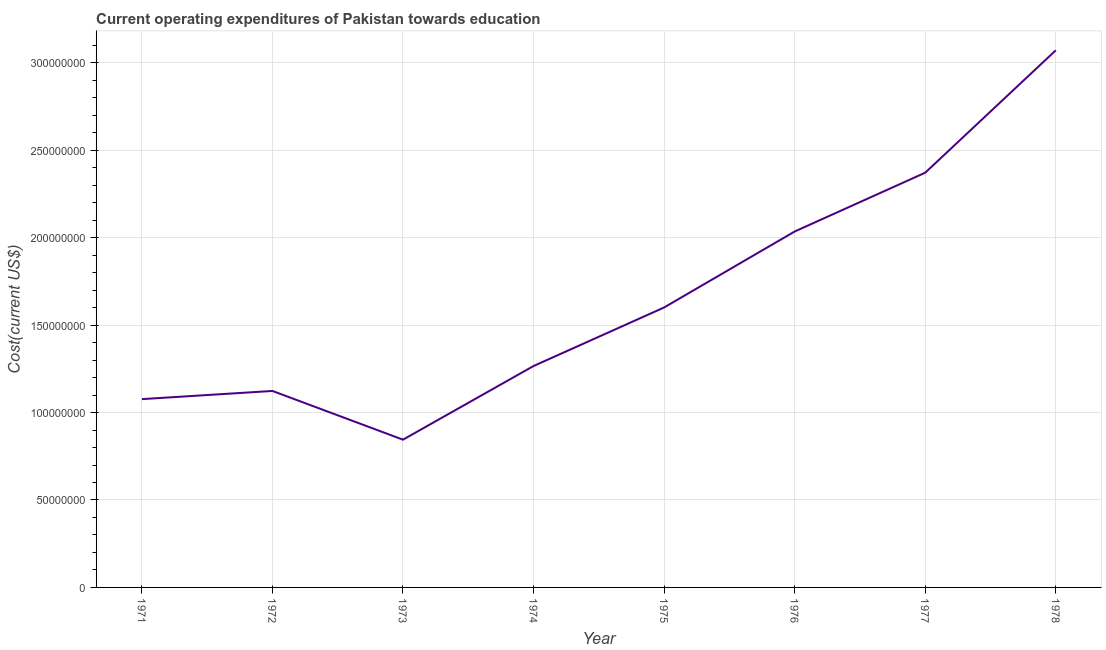What is the education expenditure in 1975?
Offer a very short reply. 1.60e+08. Across all years, what is the maximum education expenditure?
Provide a short and direct response. 3.07e+08. Across all years, what is the minimum education expenditure?
Give a very brief answer. 8.45e+07. In which year was the education expenditure maximum?
Give a very brief answer. 1978. In which year was the education expenditure minimum?
Make the answer very short. 1973. What is the sum of the education expenditure?
Your answer should be compact. 1.34e+09. What is the difference between the education expenditure in 1973 and 1976?
Ensure brevity in your answer.  -1.19e+08. What is the average education expenditure per year?
Your response must be concise. 1.67e+08. What is the median education expenditure?
Provide a short and direct response. 1.43e+08. In how many years, is the education expenditure greater than 220000000 US$?
Offer a terse response. 2. What is the ratio of the education expenditure in 1974 to that in 1977?
Keep it short and to the point. 0.53. Is the education expenditure in 1971 less than that in 1972?
Provide a short and direct response. Yes. What is the difference between the highest and the second highest education expenditure?
Make the answer very short. 7.00e+07. Is the sum of the education expenditure in 1972 and 1974 greater than the maximum education expenditure across all years?
Your response must be concise. No. What is the difference between the highest and the lowest education expenditure?
Your answer should be very brief. 2.23e+08. Does the education expenditure monotonically increase over the years?
Make the answer very short. No. How many lines are there?
Your answer should be very brief. 1. How many years are there in the graph?
Keep it short and to the point. 8. What is the difference between two consecutive major ticks on the Y-axis?
Keep it short and to the point. 5.00e+07. Does the graph contain any zero values?
Keep it short and to the point. No. What is the title of the graph?
Provide a short and direct response. Current operating expenditures of Pakistan towards education. What is the label or title of the Y-axis?
Your answer should be compact. Cost(current US$). What is the Cost(current US$) of 1971?
Provide a short and direct response. 1.08e+08. What is the Cost(current US$) of 1972?
Offer a terse response. 1.12e+08. What is the Cost(current US$) in 1973?
Your answer should be very brief. 8.45e+07. What is the Cost(current US$) of 1974?
Provide a short and direct response. 1.27e+08. What is the Cost(current US$) of 1975?
Offer a very short reply. 1.60e+08. What is the Cost(current US$) in 1976?
Offer a very short reply. 2.04e+08. What is the Cost(current US$) of 1977?
Provide a succinct answer. 2.37e+08. What is the Cost(current US$) of 1978?
Provide a short and direct response. 3.07e+08. What is the difference between the Cost(current US$) in 1971 and 1972?
Provide a succinct answer. -4.68e+06. What is the difference between the Cost(current US$) in 1971 and 1973?
Offer a terse response. 2.32e+07. What is the difference between the Cost(current US$) in 1971 and 1974?
Provide a short and direct response. -1.89e+07. What is the difference between the Cost(current US$) in 1971 and 1975?
Give a very brief answer. -5.24e+07. What is the difference between the Cost(current US$) in 1971 and 1976?
Your answer should be very brief. -9.58e+07. What is the difference between the Cost(current US$) in 1971 and 1977?
Your answer should be compact. -1.29e+08. What is the difference between the Cost(current US$) in 1971 and 1978?
Provide a succinct answer. -1.99e+08. What is the difference between the Cost(current US$) in 1972 and 1973?
Ensure brevity in your answer.  2.79e+07. What is the difference between the Cost(current US$) in 1972 and 1974?
Offer a terse response. -1.43e+07. What is the difference between the Cost(current US$) in 1972 and 1975?
Your response must be concise. -4.77e+07. What is the difference between the Cost(current US$) in 1972 and 1976?
Your answer should be very brief. -9.12e+07. What is the difference between the Cost(current US$) in 1972 and 1977?
Provide a succinct answer. -1.25e+08. What is the difference between the Cost(current US$) in 1972 and 1978?
Your answer should be very brief. -1.95e+08. What is the difference between the Cost(current US$) in 1973 and 1974?
Your answer should be compact. -4.21e+07. What is the difference between the Cost(current US$) in 1973 and 1975?
Offer a very short reply. -7.56e+07. What is the difference between the Cost(current US$) in 1973 and 1976?
Offer a terse response. -1.19e+08. What is the difference between the Cost(current US$) in 1973 and 1977?
Make the answer very short. -1.53e+08. What is the difference between the Cost(current US$) in 1973 and 1978?
Provide a succinct answer. -2.23e+08. What is the difference between the Cost(current US$) in 1974 and 1975?
Offer a very short reply. -3.35e+07. What is the difference between the Cost(current US$) in 1974 and 1976?
Ensure brevity in your answer.  -7.69e+07. What is the difference between the Cost(current US$) in 1974 and 1977?
Provide a short and direct response. -1.11e+08. What is the difference between the Cost(current US$) in 1974 and 1978?
Your answer should be very brief. -1.81e+08. What is the difference between the Cost(current US$) in 1975 and 1976?
Your response must be concise. -4.34e+07. What is the difference between the Cost(current US$) in 1975 and 1977?
Ensure brevity in your answer.  -7.71e+07. What is the difference between the Cost(current US$) in 1975 and 1978?
Ensure brevity in your answer.  -1.47e+08. What is the difference between the Cost(current US$) in 1976 and 1977?
Offer a very short reply. -3.36e+07. What is the difference between the Cost(current US$) in 1976 and 1978?
Give a very brief answer. -1.04e+08. What is the difference between the Cost(current US$) in 1977 and 1978?
Offer a very short reply. -7.00e+07. What is the ratio of the Cost(current US$) in 1971 to that in 1972?
Give a very brief answer. 0.96. What is the ratio of the Cost(current US$) in 1971 to that in 1973?
Keep it short and to the point. 1.27. What is the ratio of the Cost(current US$) in 1971 to that in 1975?
Make the answer very short. 0.67. What is the ratio of the Cost(current US$) in 1971 to that in 1976?
Make the answer very short. 0.53. What is the ratio of the Cost(current US$) in 1971 to that in 1977?
Your answer should be very brief. 0.45. What is the ratio of the Cost(current US$) in 1971 to that in 1978?
Offer a very short reply. 0.35. What is the ratio of the Cost(current US$) in 1972 to that in 1973?
Offer a terse response. 1.33. What is the ratio of the Cost(current US$) in 1972 to that in 1974?
Offer a terse response. 0.89. What is the ratio of the Cost(current US$) in 1972 to that in 1975?
Give a very brief answer. 0.7. What is the ratio of the Cost(current US$) in 1972 to that in 1976?
Provide a short and direct response. 0.55. What is the ratio of the Cost(current US$) in 1972 to that in 1977?
Make the answer very short. 0.47. What is the ratio of the Cost(current US$) in 1972 to that in 1978?
Offer a very short reply. 0.37. What is the ratio of the Cost(current US$) in 1973 to that in 1974?
Offer a very short reply. 0.67. What is the ratio of the Cost(current US$) in 1973 to that in 1975?
Give a very brief answer. 0.53. What is the ratio of the Cost(current US$) in 1973 to that in 1976?
Ensure brevity in your answer.  0.41. What is the ratio of the Cost(current US$) in 1973 to that in 1977?
Keep it short and to the point. 0.36. What is the ratio of the Cost(current US$) in 1973 to that in 1978?
Your answer should be very brief. 0.28. What is the ratio of the Cost(current US$) in 1974 to that in 1975?
Give a very brief answer. 0.79. What is the ratio of the Cost(current US$) in 1974 to that in 1976?
Offer a terse response. 0.62. What is the ratio of the Cost(current US$) in 1974 to that in 1977?
Keep it short and to the point. 0.53. What is the ratio of the Cost(current US$) in 1974 to that in 1978?
Make the answer very short. 0.41. What is the ratio of the Cost(current US$) in 1975 to that in 1976?
Provide a succinct answer. 0.79. What is the ratio of the Cost(current US$) in 1975 to that in 1977?
Ensure brevity in your answer.  0.68. What is the ratio of the Cost(current US$) in 1975 to that in 1978?
Keep it short and to the point. 0.52. What is the ratio of the Cost(current US$) in 1976 to that in 1977?
Offer a very short reply. 0.86. What is the ratio of the Cost(current US$) in 1976 to that in 1978?
Make the answer very short. 0.66. What is the ratio of the Cost(current US$) in 1977 to that in 1978?
Make the answer very short. 0.77. 